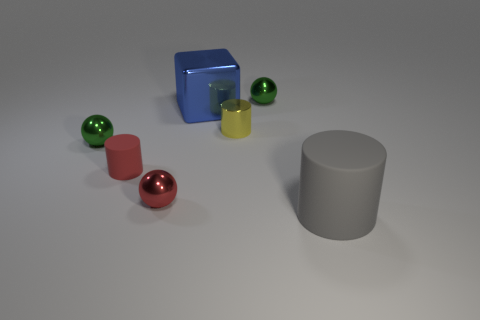Subtract all rubber cylinders. How many cylinders are left? 1 Subtract all yellow cylinders. How many cylinders are left? 2 Add 4 tiny red cylinders. How many tiny red cylinders are left? 5 Add 3 small cyan rubber cylinders. How many small cyan rubber cylinders exist? 3 Add 2 tiny red shiny objects. How many objects exist? 9 Subtract 1 green balls. How many objects are left? 6 Subtract all balls. How many objects are left? 4 Subtract 1 cylinders. How many cylinders are left? 2 Subtract all brown spheres. Subtract all gray blocks. How many spheres are left? 3 Subtract all brown blocks. How many gray cylinders are left? 1 